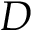Convert formula to latex. <formula><loc_0><loc_0><loc_500><loc_500>D</formula> 